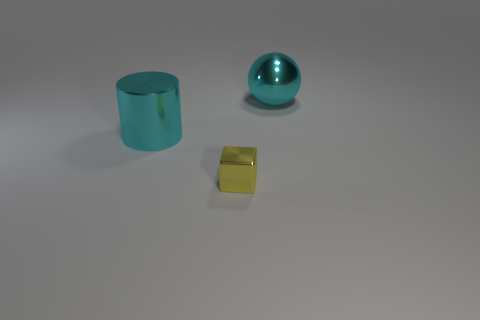Add 3 big cyan metallic spheres. How many objects exist? 6 Subtract all blocks. How many objects are left? 2 Subtract 0 green cylinders. How many objects are left? 3 Subtract all big objects. Subtract all big purple matte cylinders. How many objects are left? 1 Add 2 large cyan metal balls. How many large cyan metal balls are left? 3 Add 2 big green matte cylinders. How many big green matte cylinders exist? 2 